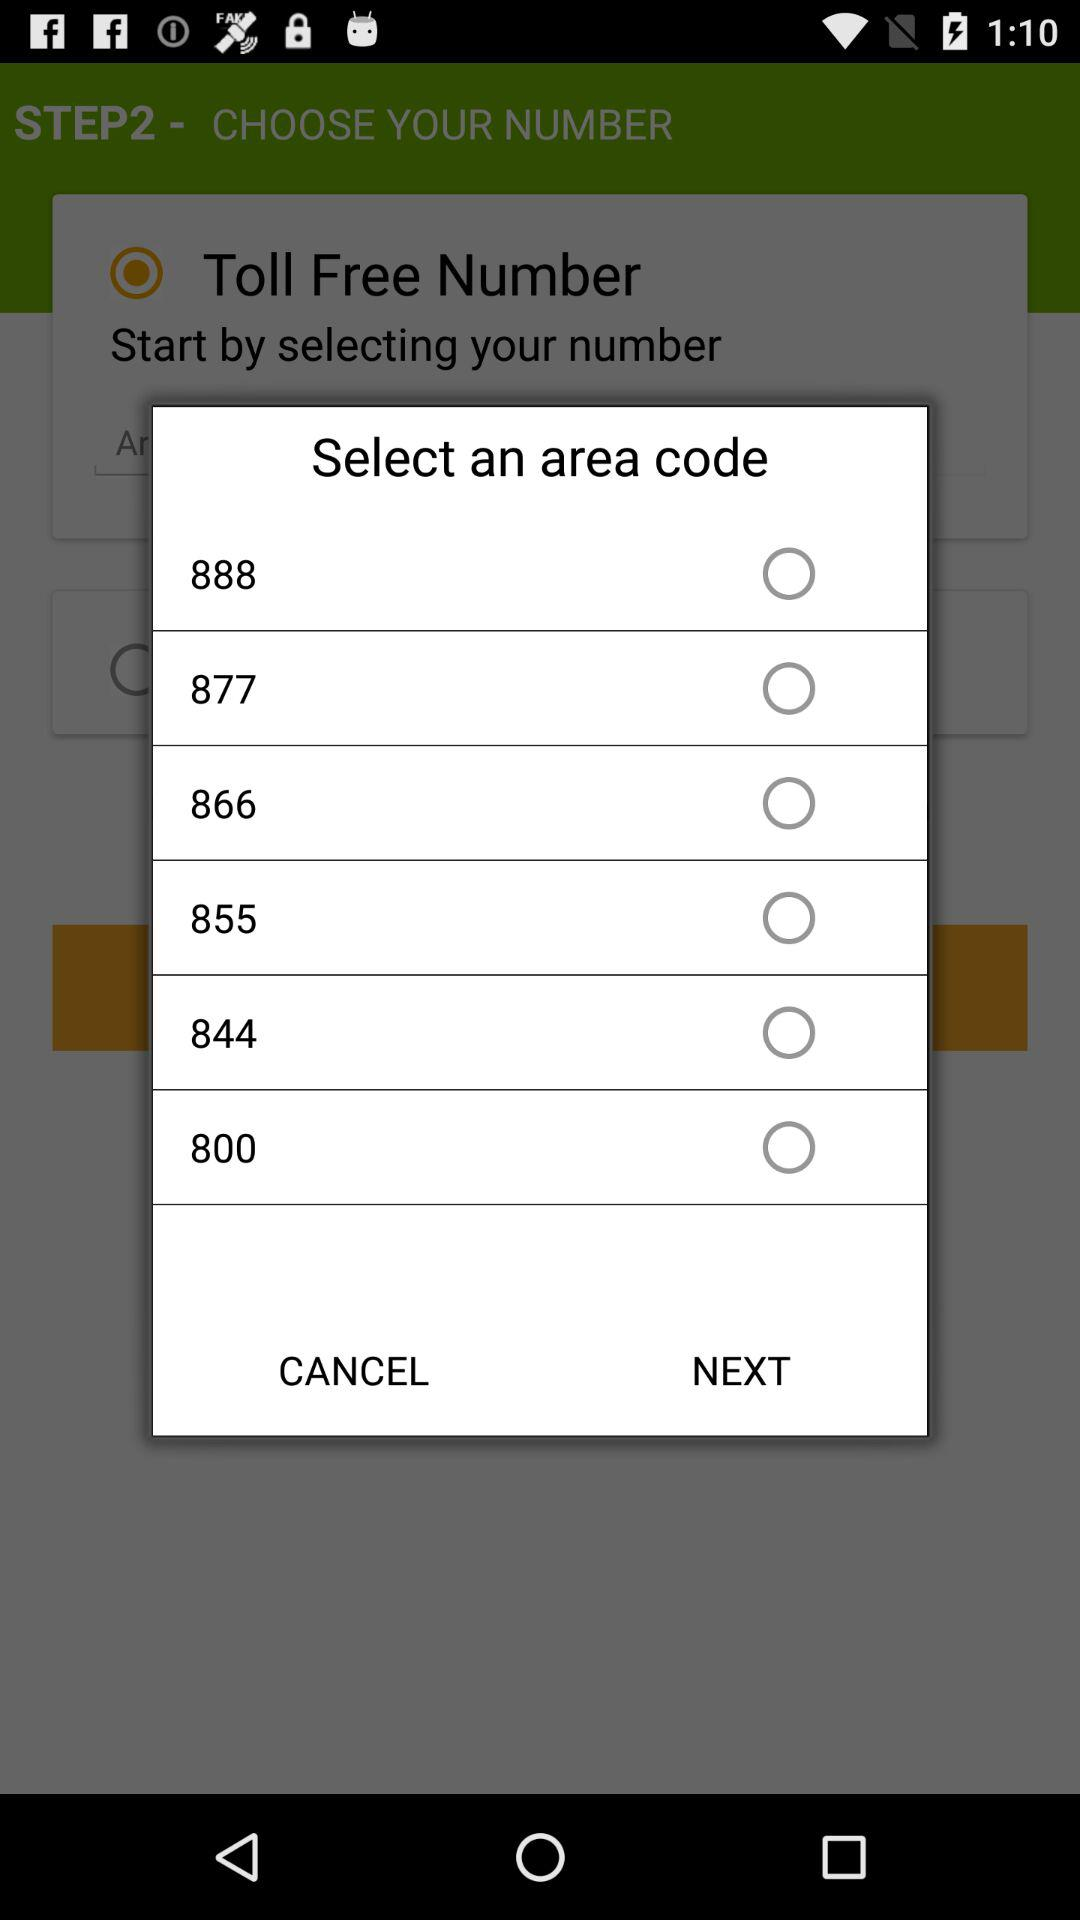Which area code is selected?
When the provided information is insufficient, respond with <no answer>. <no answer> 